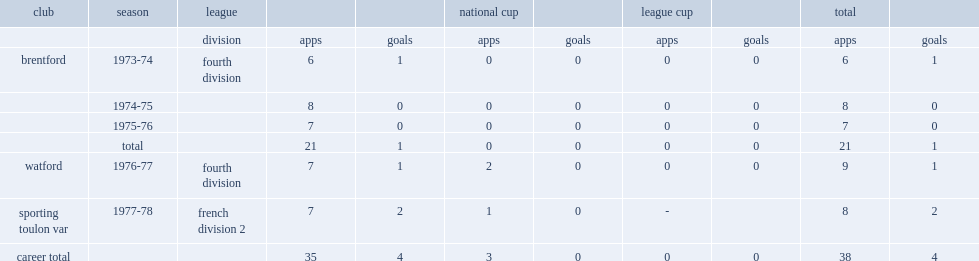How many goals did poole score for watford in 1976-77? 1.0. 